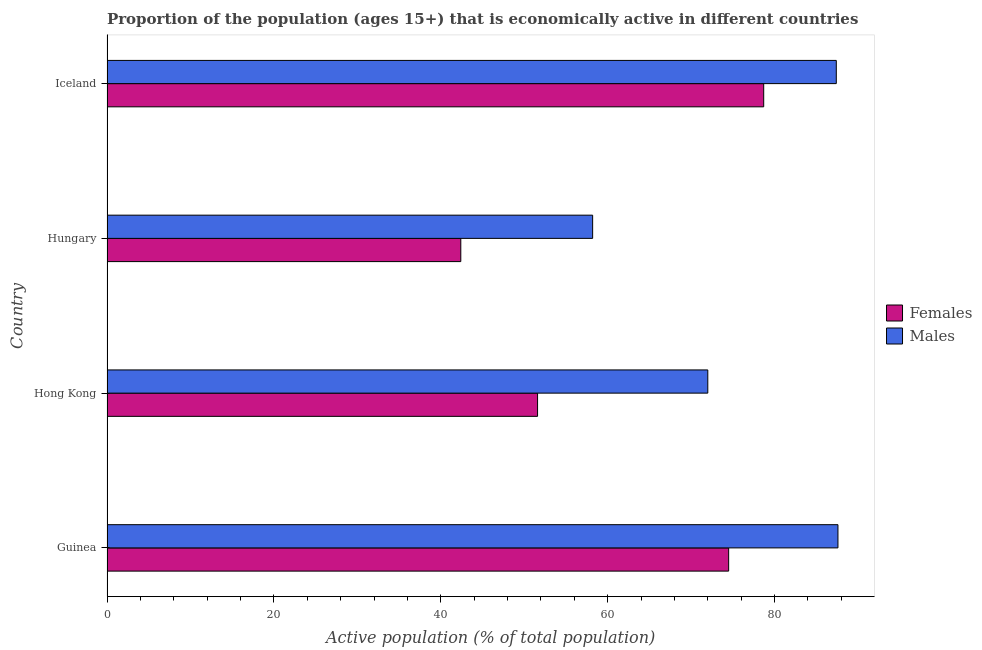Are the number of bars per tick equal to the number of legend labels?
Your answer should be very brief. Yes. How many bars are there on the 4th tick from the bottom?
Your response must be concise. 2. What is the label of the 2nd group of bars from the top?
Keep it short and to the point. Hungary. In how many cases, is the number of bars for a given country not equal to the number of legend labels?
Provide a succinct answer. 0. What is the percentage of economically active male population in Iceland?
Your answer should be very brief. 87.4. Across all countries, what is the maximum percentage of economically active male population?
Your answer should be compact. 87.6. Across all countries, what is the minimum percentage of economically active male population?
Your response must be concise. 58.2. In which country was the percentage of economically active male population maximum?
Provide a succinct answer. Guinea. In which country was the percentage of economically active female population minimum?
Offer a terse response. Hungary. What is the total percentage of economically active female population in the graph?
Make the answer very short. 247.2. What is the difference between the percentage of economically active female population in Guinea and the percentage of economically active male population in Iceland?
Offer a very short reply. -12.9. What is the average percentage of economically active male population per country?
Offer a very short reply. 76.3. What is the difference between the percentage of economically active female population and percentage of economically active male population in Hong Kong?
Ensure brevity in your answer.  -20.4. What is the ratio of the percentage of economically active male population in Hungary to that in Iceland?
Give a very brief answer. 0.67. Is the percentage of economically active female population in Guinea less than that in Hong Kong?
Keep it short and to the point. No. What is the difference between the highest and the second highest percentage of economically active female population?
Give a very brief answer. 4.2. What is the difference between the highest and the lowest percentage of economically active male population?
Provide a short and direct response. 29.4. What does the 2nd bar from the top in Guinea represents?
Make the answer very short. Females. What does the 2nd bar from the bottom in Hong Kong represents?
Offer a very short reply. Males. How many bars are there?
Your answer should be very brief. 8. Are all the bars in the graph horizontal?
Offer a very short reply. Yes. What is the difference between two consecutive major ticks on the X-axis?
Offer a terse response. 20. Are the values on the major ticks of X-axis written in scientific E-notation?
Your answer should be compact. No. Does the graph contain any zero values?
Provide a short and direct response. No. Where does the legend appear in the graph?
Offer a terse response. Center right. How many legend labels are there?
Provide a succinct answer. 2. How are the legend labels stacked?
Offer a very short reply. Vertical. What is the title of the graph?
Offer a terse response. Proportion of the population (ages 15+) that is economically active in different countries. Does "Non-pregnant women" appear as one of the legend labels in the graph?
Keep it short and to the point. No. What is the label or title of the X-axis?
Your answer should be very brief. Active population (% of total population). What is the label or title of the Y-axis?
Keep it short and to the point. Country. What is the Active population (% of total population) of Females in Guinea?
Your answer should be very brief. 74.5. What is the Active population (% of total population) of Males in Guinea?
Your response must be concise. 87.6. What is the Active population (% of total population) in Females in Hong Kong?
Make the answer very short. 51.6. What is the Active population (% of total population) of Females in Hungary?
Give a very brief answer. 42.4. What is the Active population (% of total population) in Males in Hungary?
Provide a short and direct response. 58.2. What is the Active population (% of total population) in Females in Iceland?
Ensure brevity in your answer.  78.7. What is the Active population (% of total population) of Males in Iceland?
Provide a short and direct response. 87.4. Across all countries, what is the maximum Active population (% of total population) of Females?
Your answer should be compact. 78.7. Across all countries, what is the maximum Active population (% of total population) in Males?
Offer a terse response. 87.6. Across all countries, what is the minimum Active population (% of total population) of Females?
Provide a short and direct response. 42.4. Across all countries, what is the minimum Active population (% of total population) of Males?
Your answer should be very brief. 58.2. What is the total Active population (% of total population) of Females in the graph?
Ensure brevity in your answer.  247.2. What is the total Active population (% of total population) in Males in the graph?
Make the answer very short. 305.2. What is the difference between the Active population (% of total population) of Females in Guinea and that in Hong Kong?
Provide a succinct answer. 22.9. What is the difference between the Active population (% of total population) of Females in Guinea and that in Hungary?
Ensure brevity in your answer.  32.1. What is the difference between the Active population (% of total population) in Males in Guinea and that in Hungary?
Provide a succinct answer. 29.4. What is the difference between the Active population (% of total population) in Females in Guinea and that in Iceland?
Your answer should be compact. -4.2. What is the difference between the Active population (% of total population) of Males in Guinea and that in Iceland?
Make the answer very short. 0.2. What is the difference between the Active population (% of total population) of Females in Hong Kong and that in Hungary?
Ensure brevity in your answer.  9.2. What is the difference between the Active population (% of total population) in Males in Hong Kong and that in Hungary?
Keep it short and to the point. 13.8. What is the difference between the Active population (% of total population) in Females in Hong Kong and that in Iceland?
Make the answer very short. -27.1. What is the difference between the Active population (% of total population) of Males in Hong Kong and that in Iceland?
Provide a succinct answer. -15.4. What is the difference between the Active population (% of total population) of Females in Hungary and that in Iceland?
Your answer should be compact. -36.3. What is the difference between the Active population (% of total population) in Males in Hungary and that in Iceland?
Keep it short and to the point. -29.2. What is the difference between the Active population (% of total population) in Females in Guinea and the Active population (% of total population) in Males in Iceland?
Give a very brief answer. -12.9. What is the difference between the Active population (% of total population) of Females in Hong Kong and the Active population (% of total population) of Males in Hungary?
Ensure brevity in your answer.  -6.6. What is the difference between the Active population (% of total population) in Females in Hong Kong and the Active population (% of total population) in Males in Iceland?
Keep it short and to the point. -35.8. What is the difference between the Active population (% of total population) in Females in Hungary and the Active population (% of total population) in Males in Iceland?
Keep it short and to the point. -45. What is the average Active population (% of total population) in Females per country?
Make the answer very short. 61.8. What is the average Active population (% of total population) in Males per country?
Keep it short and to the point. 76.3. What is the difference between the Active population (% of total population) of Females and Active population (% of total population) of Males in Guinea?
Ensure brevity in your answer.  -13.1. What is the difference between the Active population (% of total population) of Females and Active population (% of total population) of Males in Hong Kong?
Provide a succinct answer. -20.4. What is the difference between the Active population (% of total population) of Females and Active population (% of total population) of Males in Hungary?
Provide a short and direct response. -15.8. What is the difference between the Active population (% of total population) in Females and Active population (% of total population) in Males in Iceland?
Provide a short and direct response. -8.7. What is the ratio of the Active population (% of total population) of Females in Guinea to that in Hong Kong?
Your answer should be compact. 1.44. What is the ratio of the Active population (% of total population) in Males in Guinea to that in Hong Kong?
Provide a short and direct response. 1.22. What is the ratio of the Active population (% of total population) of Females in Guinea to that in Hungary?
Provide a short and direct response. 1.76. What is the ratio of the Active population (% of total population) in Males in Guinea to that in Hungary?
Your answer should be very brief. 1.51. What is the ratio of the Active population (% of total population) of Females in Guinea to that in Iceland?
Ensure brevity in your answer.  0.95. What is the ratio of the Active population (% of total population) of Females in Hong Kong to that in Hungary?
Your response must be concise. 1.22. What is the ratio of the Active population (% of total population) of Males in Hong Kong to that in Hungary?
Provide a short and direct response. 1.24. What is the ratio of the Active population (% of total population) of Females in Hong Kong to that in Iceland?
Your response must be concise. 0.66. What is the ratio of the Active population (% of total population) in Males in Hong Kong to that in Iceland?
Offer a very short reply. 0.82. What is the ratio of the Active population (% of total population) in Females in Hungary to that in Iceland?
Provide a short and direct response. 0.54. What is the ratio of the Active population (% of total population) in Males in Hungary to that in Iceland?
Provide a short and direct response. 0.67. What is the difference between the highest and the lowest Active population (% of total population) of Females?
Make the answer very short. 36.3. What is the difference between the highest and the lowest Active population (% of total population) in Males?
Your response must be concise. 29.4. 